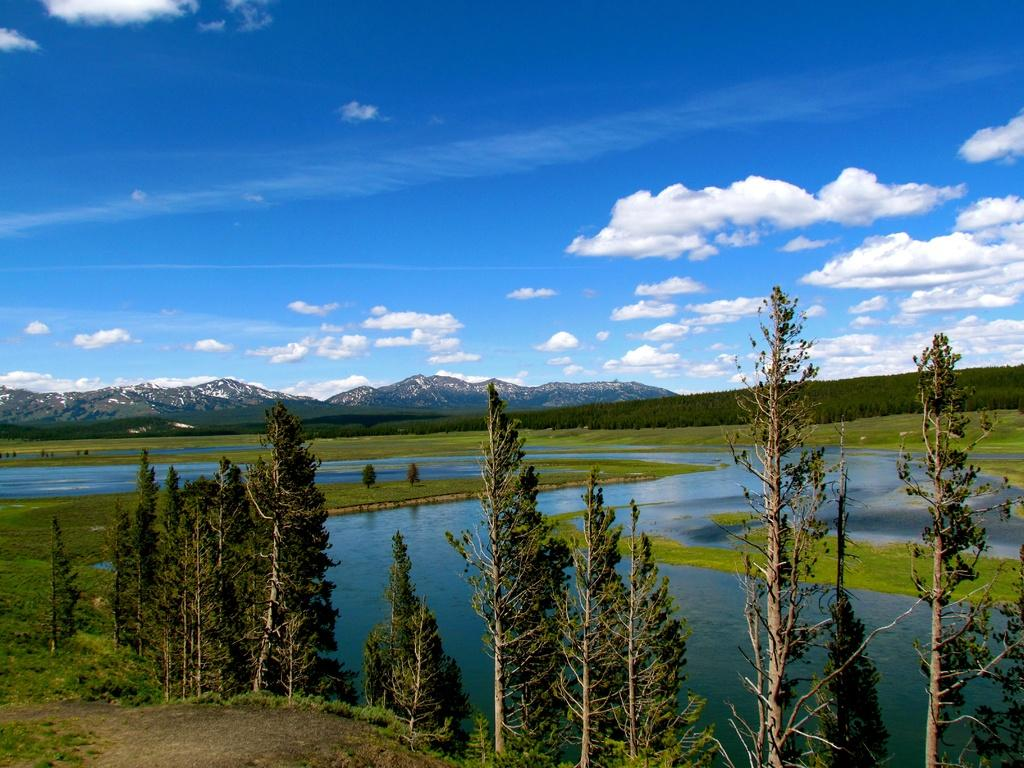What type of vegetation can be seen in the image? There are trees in the image. What is the ground covered with in the image? There is grass in the image. What natural feature can be seen in the image besides vegetation? There is water visible in the image. What type of landscape is depicted in the image? There are hills in the image. What is visible above the landscape in the image? The sky is visible in the image. How many feet of wire are visible in the image? There is no wire present in the image. Can you see anyone swimming in the water in the image? There is no one swimming in the water in the image. 